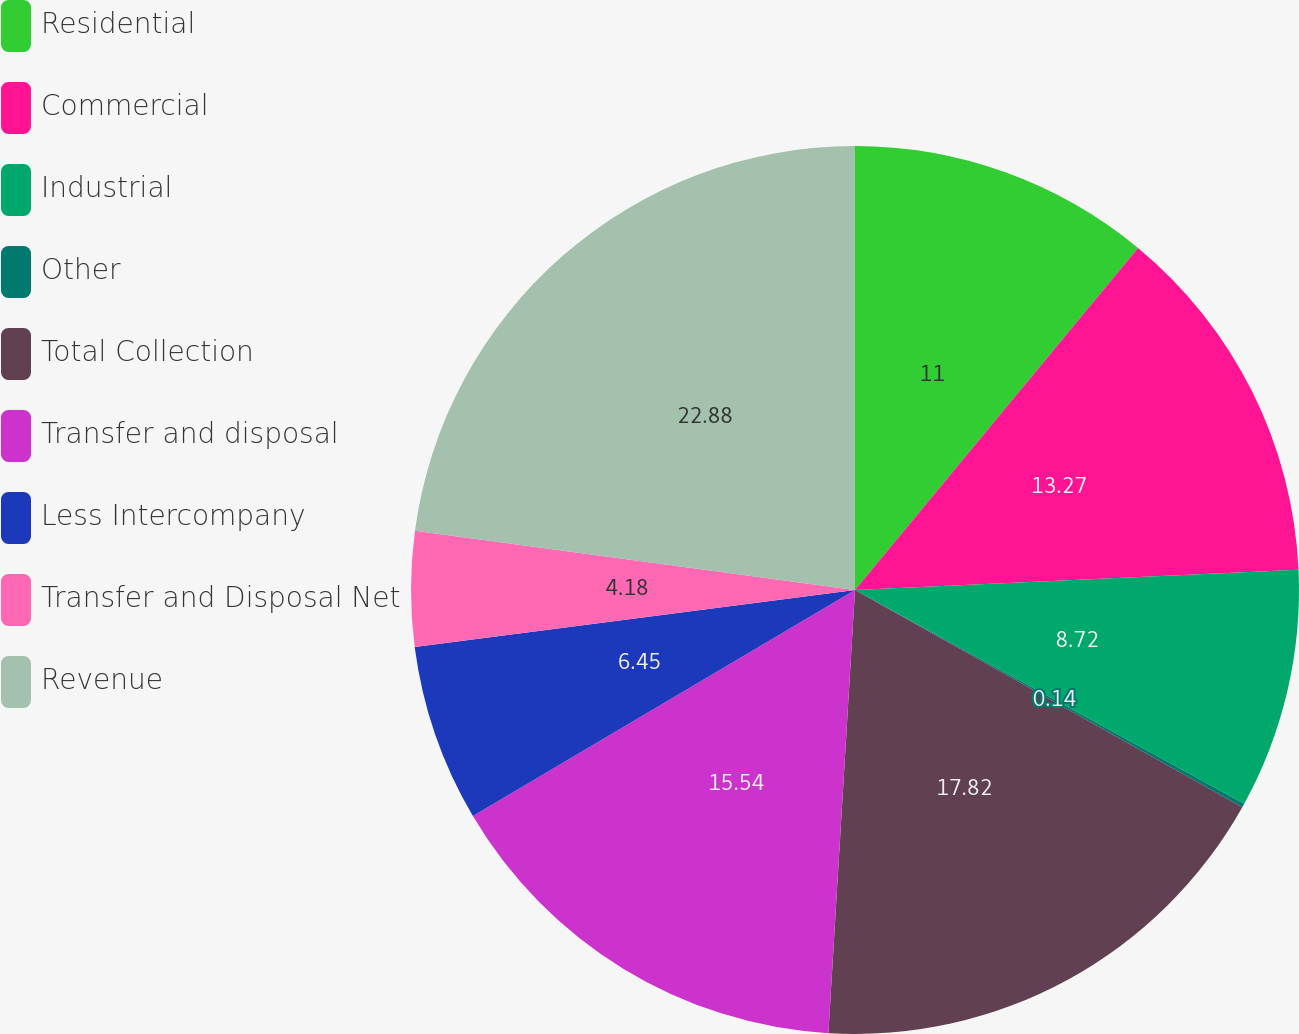Convert chart to OTSL. <chart><loc_0><loc_0><loc_500><loc_500><pie_chart><fcel>Residential<fcel>Commercial<fcel>Industrial<fcel>Other<fcel>Total Collection<fcel>Transfer and disposal<fcel>Less Intercompany<fcel>Transfer and Disposal Net<fcel>Revenue<nl><fcel>11.0%<fcel>13.27%<fcel>8.72%<fcel>0.14%<fcel>17.82%<fcel>15.54%<fcel>6.45%<fcel>4.18%<fcel>22.87%<nl></chart> 